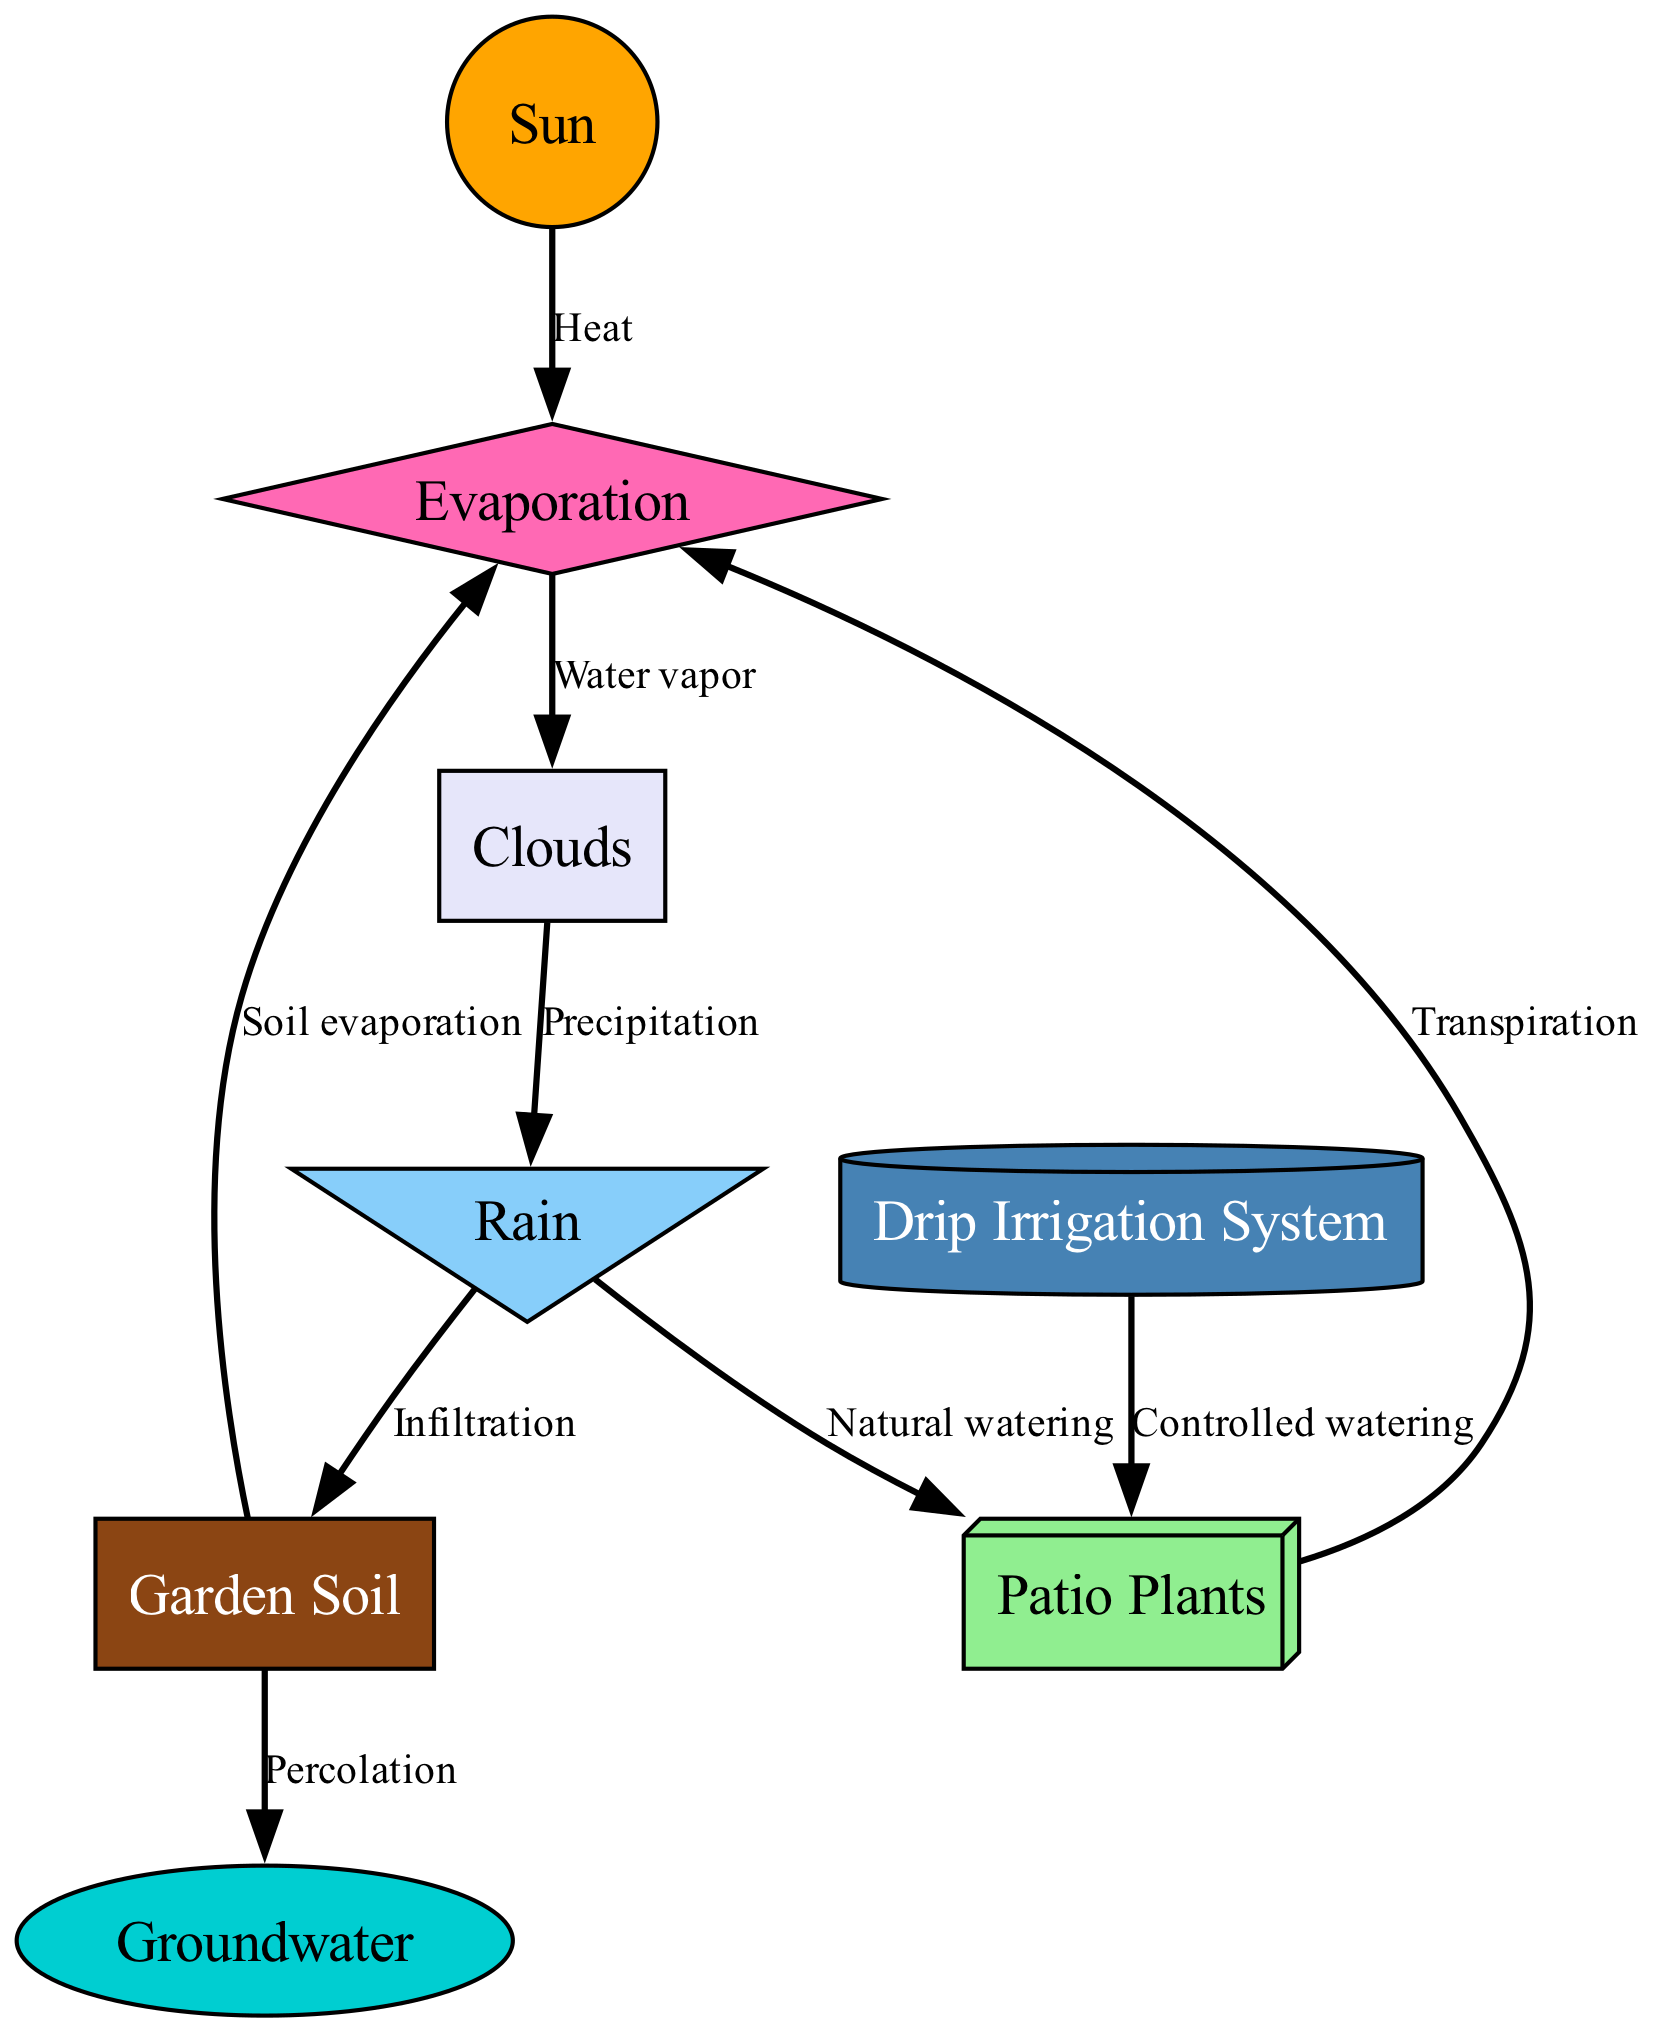What is the source of water vapor in the diagram? The source of water vapor in the diagram is indicated by the connection from the evaporation node to the clouds node. It shows that the process of evaporation, driven by the sun's heat, converts water into vapor that moves into clouds.
Answer: Water vapor How many nodes are present in the diagram? The diagram contains eight nodes: Sun, Clouds, Rain, Patio Plants, Garden Soil, Drip Irrigation System, Groundwater, and Evaporation. Counting these gives a total of eight nodes.
Answer: Eight What type of watering is represented by the irrigation connection? The irrigation connection to the plants is labeled as "Controlled watering," which indicates that it is a method of supplying water to the plants using an irrigation system.
Answer: Controlled watering What is the relationship between rain and soil in the diagram? The relationship between rain and soil is illustrated by two edges: one labeled "Infiltration" from rain to soil and one labeled "Natural watering" from rain to plants. Infiltration indicates that rainwater seeps into the soil while also watering the plants naturally.
Answer: Infiltration and Natural watering What is the function of the transpiration connection? The transpiration connection from patio plants to evaporation indicates the process by which plants release water vapor into the atmosphere. This shows how plants contribute to the water cycle by returning water to the air.
Answer: Transpiration 